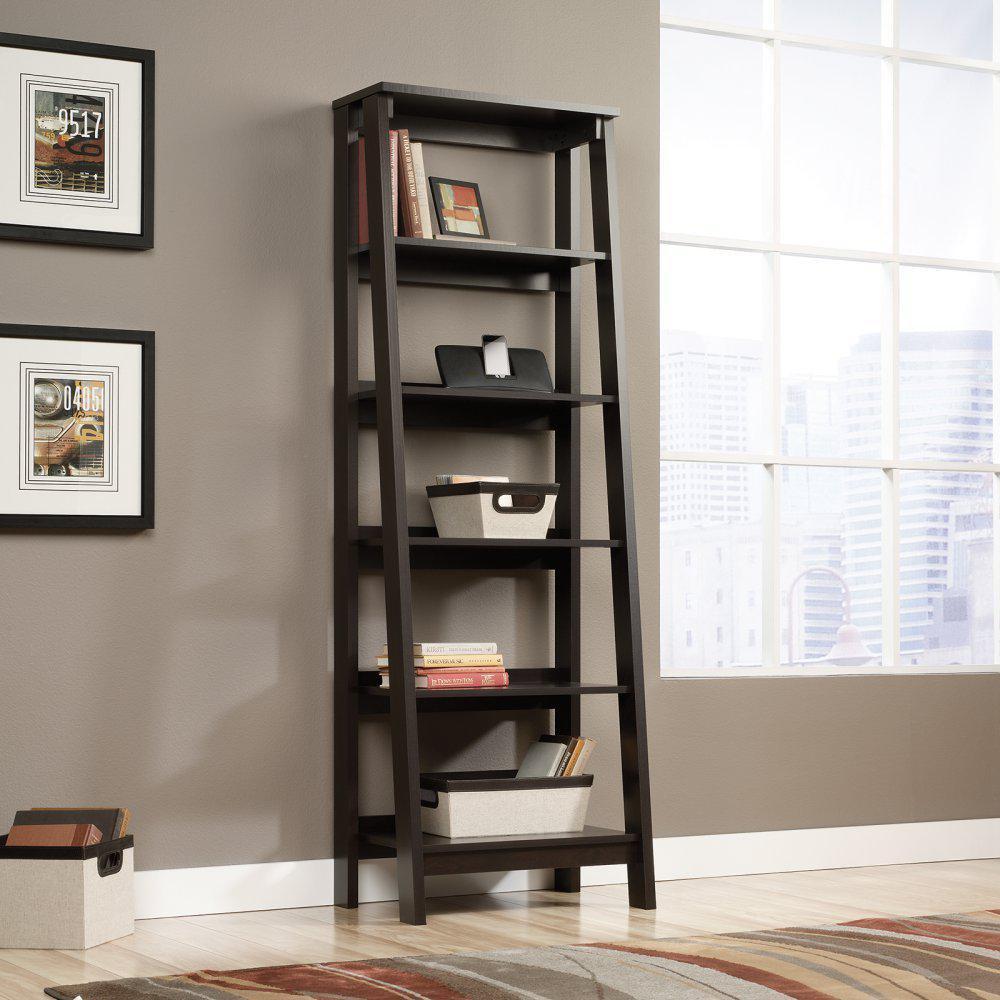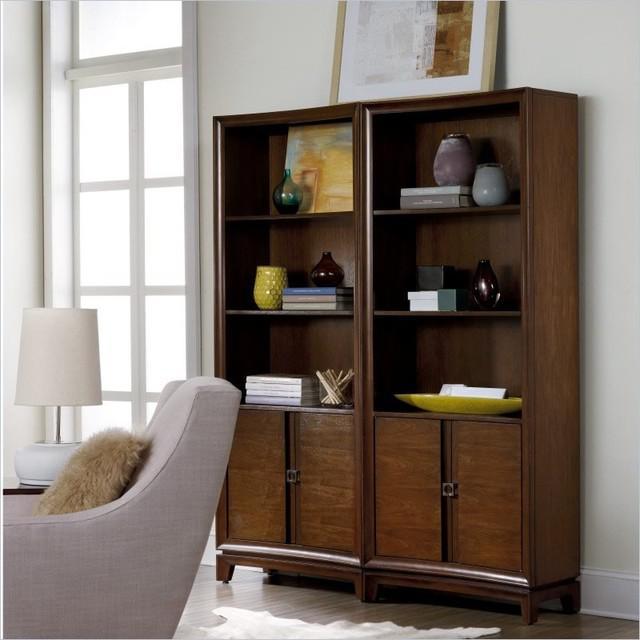The first image is the image on the left, the second image is the image on the right. Assess this claim about the two images: "An image shows a white storage unit with at least one item on its flat top.". Correct or not? Answer yes or no. No. 